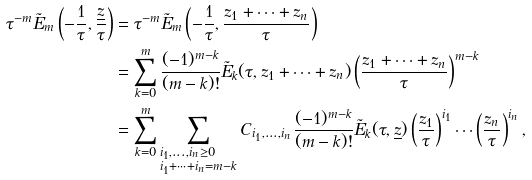Convert formula to latex. <formula><loc_0><loc_0><loc_500><loc_500>\tau ^ { - m } \tilde { E } _ { m } \left ( - \frac { 1 } { \tau } , \frac { \underline { z } } { \tau } \right ) & = \tau ^ { - m } \tilde { E } _ { m } \left ( - \frac { 1 } { \tau } , \frac { z _ { 1 } + \cdots + z _ { n } } { \tau } \right ) \\ & = \sum _ { k = 0 } ^ { m } \frac { ( - 1 ) ^ { m - k } } { ( m - k ) ! } \tilde { E } _ { k } ( \tau , z _ { 1 } + \cdots + z _ { n } ) \left ( \frac { z _ { 1 } + \cdots + z _ { n } } { \tau } \right ) ^ { m - k } \\ & = \sum _ { k = 0 } ^ { m } \sum _ { \begin{subarray} { c } i _ { 1 } , \dots , i _ { n } \geq 0 \\ i _ { 1 } + \cdots + i _ { n } = m - k \end{subarray} } C _ { i _ { 1 } , \dots , i _ { n } } \frac { ( - 1 ) ^ { m - k } } { ( m - k ) ! } \tilde { E } _ { k } ( \tau , \underline { z } ) \left ( \frac { z _ { 1 } } { \tau } \right ) ^ { i _ { 1 } } \cdots \left ( \frac { z _ { n } } { \tau } \right ) ^ { i _ { n } } ,</formula> 